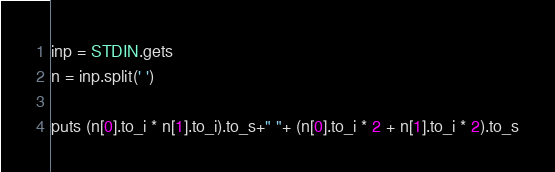<code> <loc_0><loc_0><loc_500><loc_500><_Ruby_>inp = STDIN.gets
n = inp.split(' ')

puts (n[0].to_i * n[1].to_i).to_s+" "+ (n[0].to_i * 2 + n[1].to_i * 2).to_s</code> 